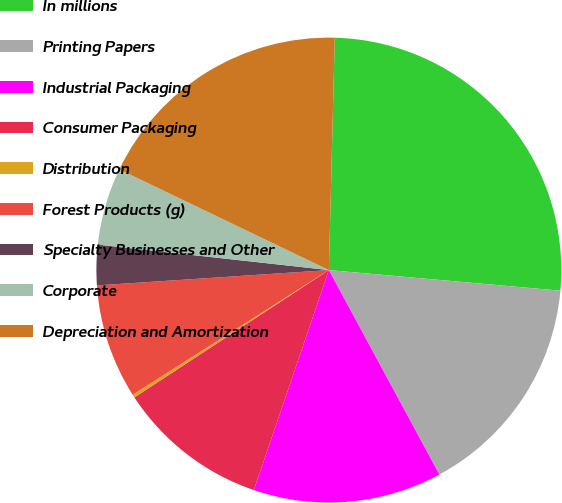Convert chart to OTSL. <chart><loc_0><loc_0><loc_500><loc_500><pie_chart><fcel>In millions<fcel>Printing Papers<fcel>Industrial Packaging<fcel>Consumer Packaging<fcel>Distribution<fcel>Forest Products (g)<fcel>Specialty Businesses and Other<fcel>Corporate<fcel>Depreciation and Amortization<nl><fcel>26.01%<fcel>15.7%<fcel>13.12%<fcel>10.54%<fcel>0.22%<fcel>7.96%<fcel>2.8%<fcel>5.38%<fcel>18.28%<nl></chart> 